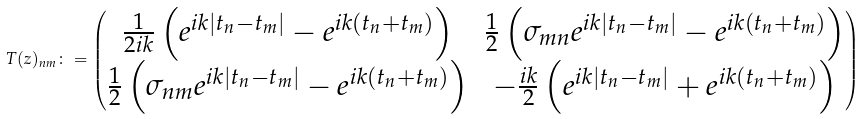<formula> <loc_0><loc_0><loc_500><loc_500>T ( z ) _ { n m } \colon = \begin{pmatrix} \frac { 1 } { 2 i k } \left ( e ^ { i k | t _ { n } - t _ { m } | } - e ^ { i k ( t _ { n } + t _ { m } ) } \right ) & \frac { 1 } { 2 } \left ( \sigma _ { m n } e ^ { i k | t _ { n } - t _ { m } | } - e ^ { i k ( t _ { n } + t _ { m } ) } \right ) \\ \frac { 1 } { 2 } \left ( \sigma _ { n m } e ^ { i k | t _ { n } - t _ { m } | } - e ^ { i k ( t _ { n } + t _ { m } ) } \right ) & - \frac { i k } { 2 } \left ( e ^ { i k | t _ { n } - t _ { m } | } + e ^ { i k ( t _ { n } + t _ { m } ) } \right ) \end{pmatrix} \,</formula> 